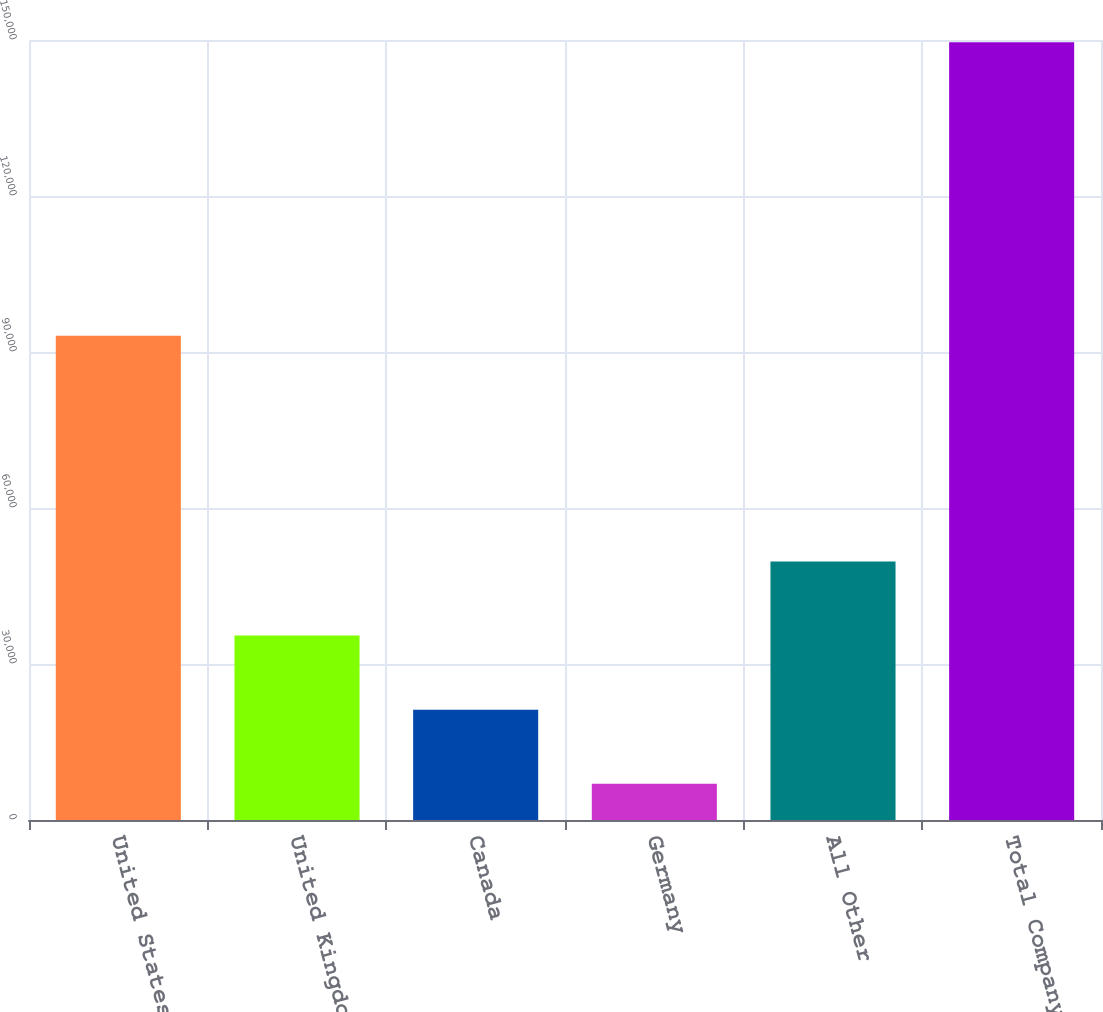Convert chart. <chart><loc_0><loc_0><loc_500><loc_500><bar_chart><fcel>United States<fcel>United Kingdom<fcel>Canada<fcel>Germany<fcel>All Other<fcel>Total Company<nl><fcel>93142<fcel>35471.6<fcel>21210.8<fcel>6950<fcel>49732.4<fcel>149558<nl></chart> 